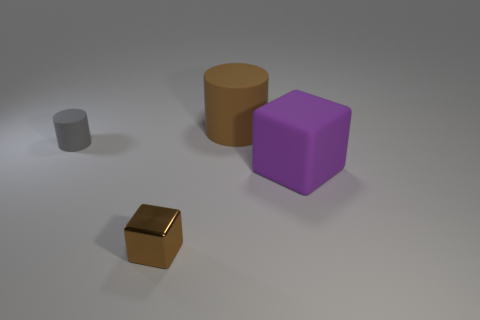There is a large matte thing to the left of the big purple object; what number of things are to the right of it?
Provide a short and direct response. 1. There is a matte thing that is right of the large cylinder; does it have the same shape as the small rubber thing to the left of the large matte block?
Your answer should be very brief. No. What is the shape of the object that is the same color as the large rubber cylinder?
Give a very brief answer. Cube. Is there a big green object made of the same material as the large purple block?
Your answer should be compact. No. What number of metallic objects are either big green blocks or purple cubes?
Your answer should be very brief. 0. What is the shape of the rubber thing that is on the left side of the object in front of the large purple rubber object?
Make the answer very short. Cylinder. Is the number of matte things that are left of the large purple matte block less than the number of small gray cylinders?
Offer a very short reply. No. There is a tiny brown thing; what shape is it?
Provide a succinct answer. Cube. There is a rubber object left of the brown block; how big is it?
Provide a short and direct response. Small. What is the color of the other thing that is the same size as the gray rubber thing?
Offer a very short reply. Brown. 